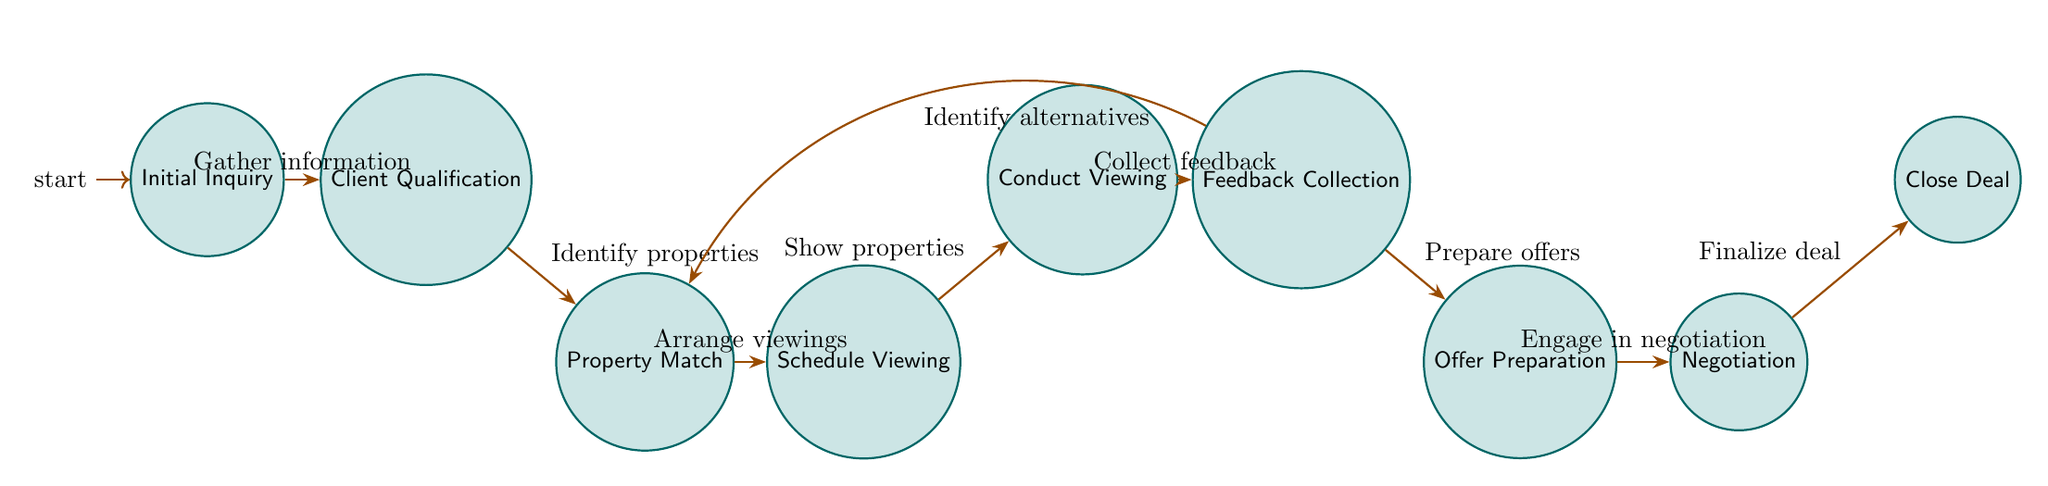What is the first state in the inquiry process? The diagram starts at the "Initial Inquiry" state, which represents the first step when the client reaches out.
Answer: Initial Inquiry How many total states are in the diagram? By counting all the distinct states listed, there are a total of nine states in the inquiry process.
Answer: 9 What action leads from "Conduct Viewing" to "Feedback Collection"? The edge connecting these two states is labeled "Collect feedback," indicating that after conducting viewings, the agent gathers feedback from the client.
Answer: Collect feedback What action occurs after "Client Qualification"? The transition following "Client Qualification" leads to "Property Match" with the action "Identify suitable properties," indicating that after assessing the client’s needs, the agent identifies properties that fit those needs.
Answer: Identify suitable properties Is there an alternative path from "Feedback Collection"? Yes, after "Feedback Collection," if the client is not satisfied with the properties, the path can lead back to "Property Match" with the action "Identify alternative properties."
Answer: Yes What is the last state in the inquiry process? The inquiry process ends at the "Close Deal" state, which represents the finalization of the agreement and completion of paperwork.
Answer: Close Deal What action bridges from "Offer Preparation" to "Negotiation"? The transition from "Offer Preparation" to "Negotiation" is represented by the action "Engage in negotiation process," which indicates that after preparing offers, the agent negotiates terms with the seller's agent.
Answer: Engage in negotiation process How are the states "Feedback Collection" and "Property Match" connected? The states are connected by a transition labeled "Identify alternatives," allowing the process to loop back if the client needs to consider other properties based on the feedback given.
Answer: Identify alternatives How many transitions are there between the states? Counting all the directed edges in the diagram, there are a total of eight transitions that represent actions taken between states.
Answer: 8 